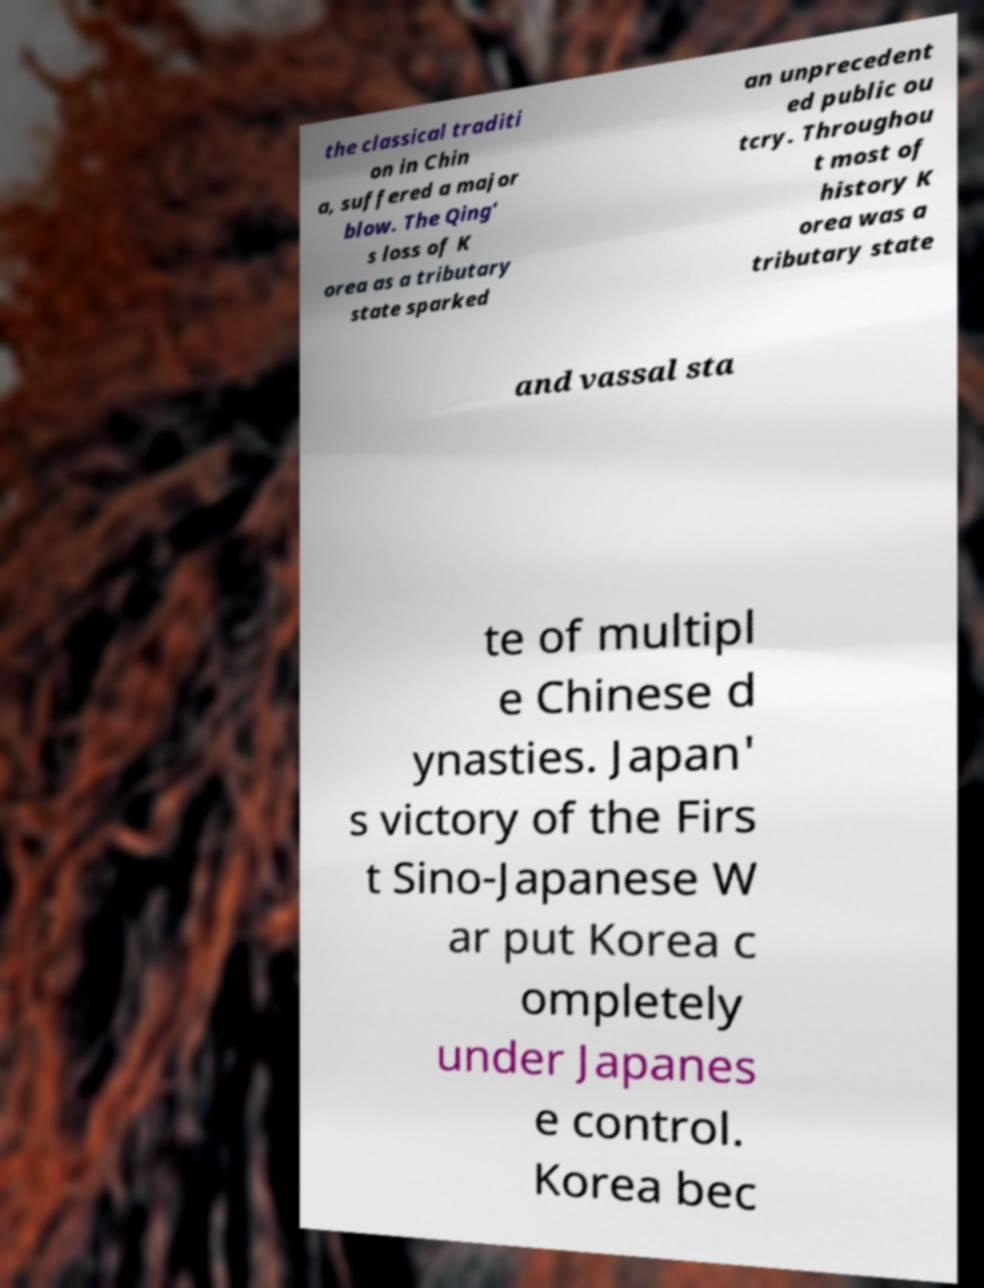There's text embedded in this image that I need extracted. Can you transcribe it verbatim? the classical traditi on in Chin a, suffered a major blow. The Qing' s loss of K orea as a tributary state sparked an unprecedent ed public ou tcry. Throughou t most of history K orea was a tributary state and vassal sta te of multipl e Chinese d ynasties. Japan' s victory of the Firs t Sino-Japanese W ar put Korea c ompletely under Japanes e control. Korea bec 